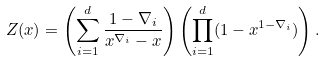<formula> <loc_0><loc_0><loc_500><loc_500>Z ( x ) = \left ( \sum _ { i = 1 } ^ { d } \frac { 1 - \nabla _ { i } } { x ^ { \nabla _ { i } } - x } \right ) \left ( \prod _ { i = 1 } ^ { d } ( 1 - x ^ { 1 - \nabla _ { i } } ) \right ) .</formula> 